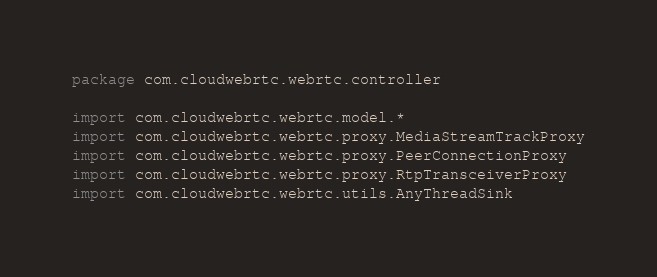<code> <loc_0><loc_0><loc_500><loc_500><_Kotlin_>package com.cloudwebrtc.webrtc.controller

import com.cloudwebrtc.webrtc.model.*
import com.cloudwebrtc.webrtc.proxy.MediaStreamTrackProxy
import com.cloudwebrtc.webrtc.proxy.PeerConnectionProxy
import com.cloudwebrtc.webrtc.proxy.RtpTransceiverProxy
import com.cloudwebrtc.webrtc.utils.AnyThreadSink</code> 